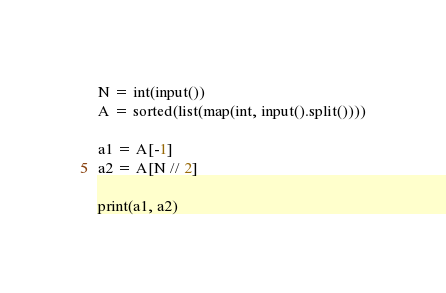<code> <loc_0><loc_0><loc_500><loc_500><_Python_>N = int(input())
A = sorted(list(map(int, input().split())))

a1 = A[-1]
a2 = A[N // 2]

print(a1, a2)</code> 